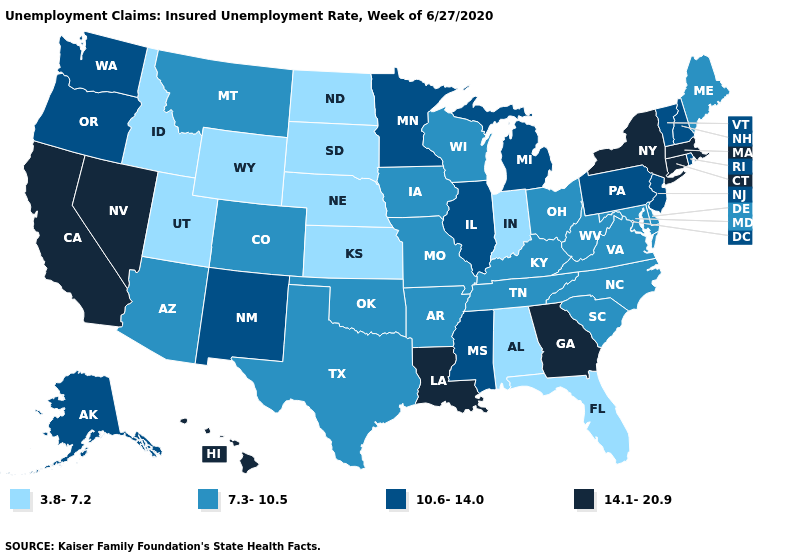Name the states that have a value in the range 10.6-14.0?
Be succinct. Alaska, Illinois, Michigan, Minnesota, Mississippi, New Hampshire, New Jersey, New Mexico, Oregon, Pennsylvania, Rhode Island, Vermont, Washington. Does Georgia have the highest value in the USA?
Be succinct. Yes. Does the first symbol in the legend represent the smallest category?
Give a very brief answer. Yes. What is the highest value in states that border South Carolina?
Write a very short answer. 14.1-20.9. Does the first symbol in the legend represent the smallest category?
Give a very brief answer. Yes. What is the value of Mississippi?
Quick response, please. 10.6-14.0. What is the highest value in the USA?
Write a very short answer. 14.1-20.9. What is the lowest value in states that border Rhode Island?
Quick response, please. 14.1-20.9. Does the map have missing data?
Concise answer only. No. Name the states that have a value in the range 3.8-7.2?
Concise answer only. Alabama, Florida, Idaho, Indiana, Kansas, Nebraska, North Dakota, South Dakota, Utah, Wyoming. Does Kansas have the lowest value in the MidWest?
Give a very brief answer. Yes. What is the highest value in the South ?
Answer briefly. 14.1-20.9. Does the first symbol in the legend represent the smallest category?
Write a very short answer. Yes. What is the value of Rhode Island?
Give a very brief answer. 10.6-14.0. What is the value of New Jersey?
Write a very short answer. 10.6-14.0. 